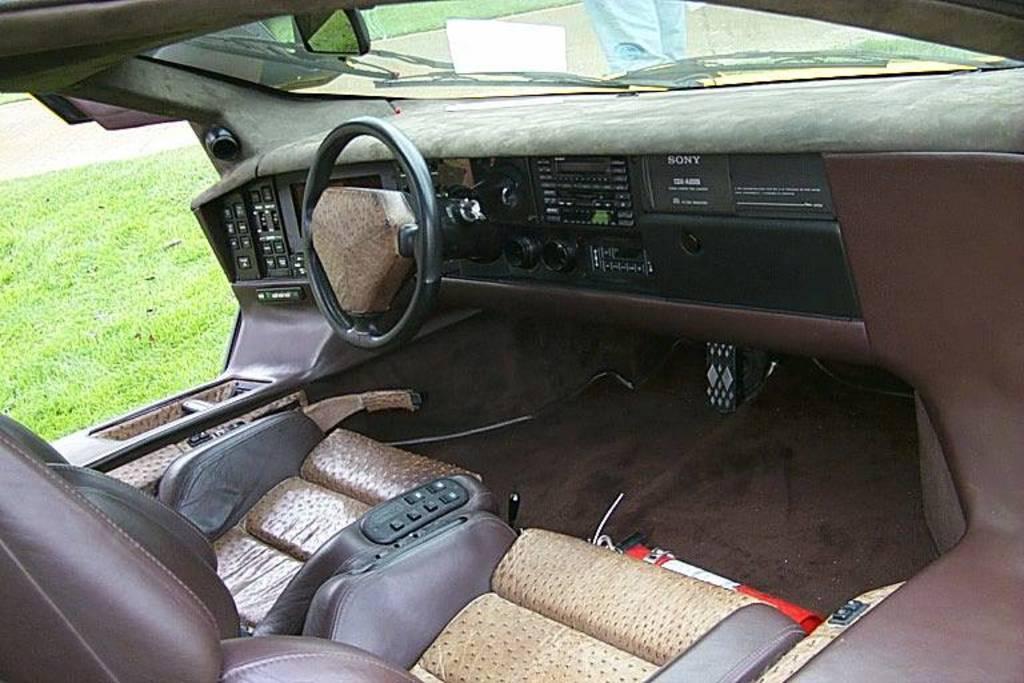How would you summarize this image in a sentence or two? This is clicked inside a car, on the left side there is grassland and a person standing in the front. 